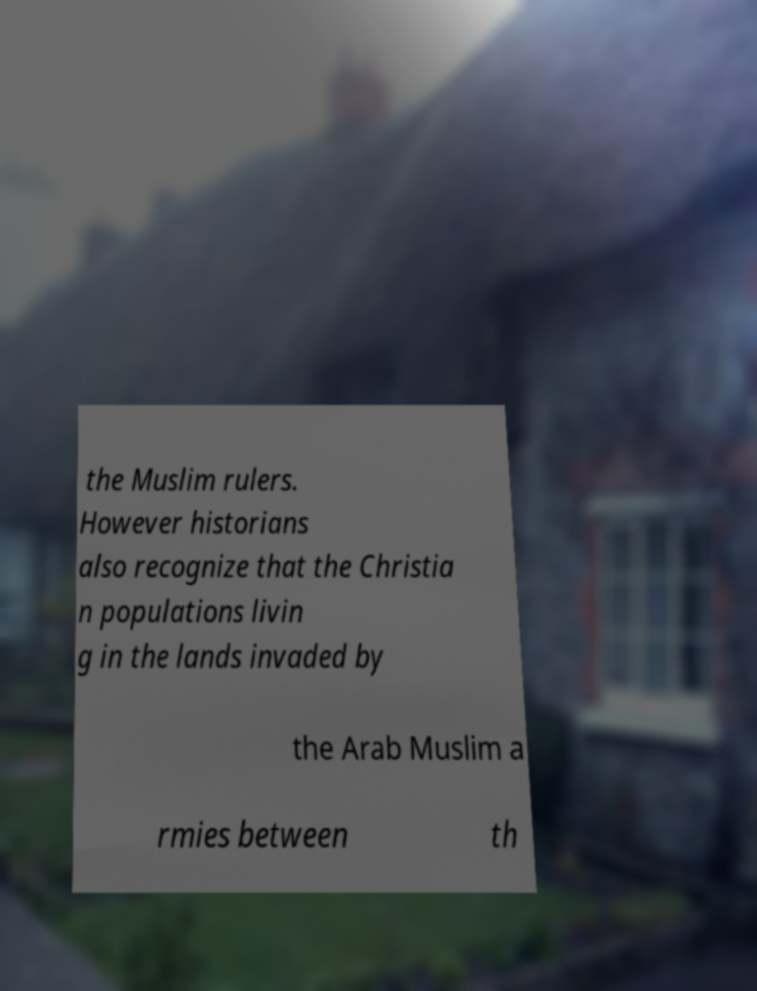Could you assist in decoding the text presented in this image and type it out clearly? the Muslim rulers. However historians also recognize that the Christia n populations livin g in the lands invaded by the Arab Muslim a rmies between th 